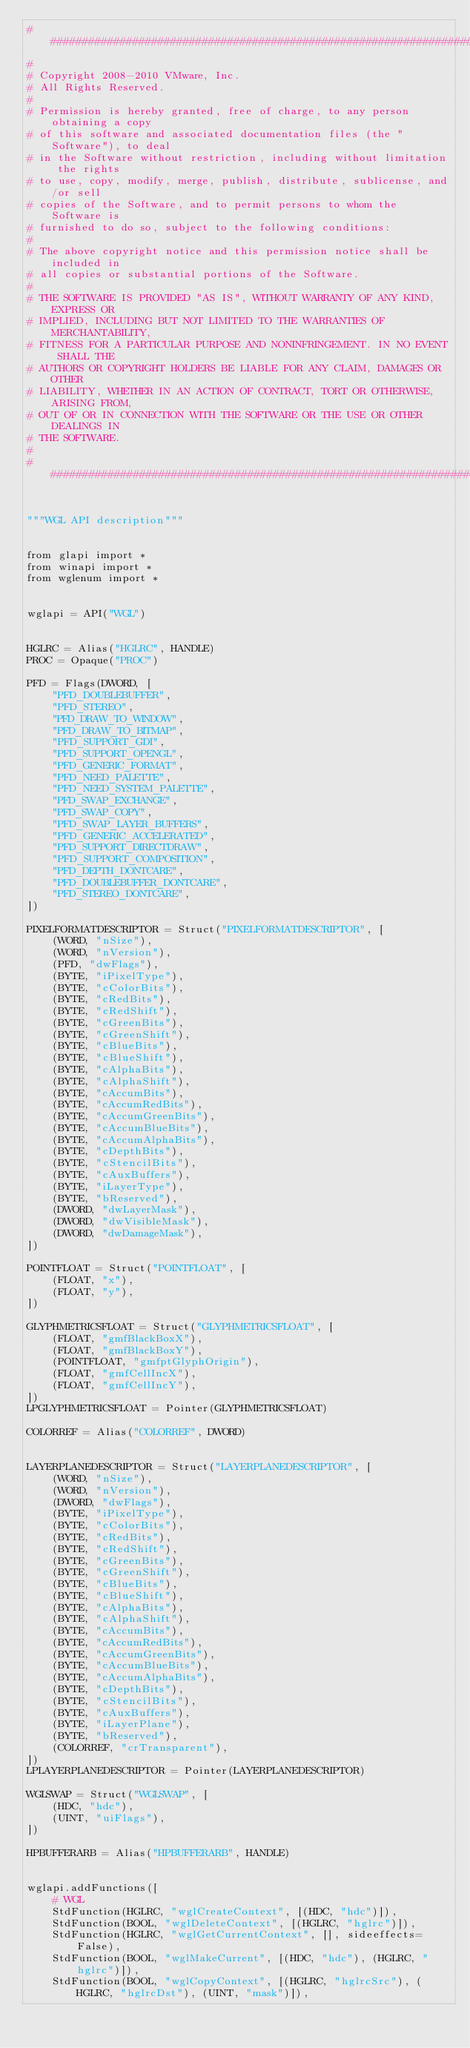Convert code to text. <code><loc_0><loc_0><loc_500><loc_500><_Python_>##########################################################################
#
# Copyright 2008-2010 VMware, Inc.
# All Rights Reserved.
#
# Permission is hereby granted, free of charge, to any person obtaining a copy
# of this software and associated documentation files (the "Software"), to deal
# in the Software without restriction, including without limitation the rights
# to use, copy, modify, merge, publish, distribute, sublicense, and/or sell
# copies of the Software, and to permit persons to whom the Software is
# furnished to do so, subject to the following conditions:
#
# The above copyright notice and this permission notice shall be included in
# all copies or substantial portions of the Software.
#
# THE SOFTWARE IS PROVIDED "AS IS", WITHOUT WARRANTY OF ANY KIND, EXPRESS OR
# IMPLIED, INCLUDING BUT NOT LIMITED TO THE WARRANTIES OF MERCHANTABILITY,
# FITNESS FOR A PARTICULAR PURPOSE AND NONINFRINGEMENT. IN NO EVENT SHALL THE
# AUTHORS OR COPYRIGHT HOLDERS BE LIABLE FOR ANY CLAIM, DAMAGES OR OTHER
# LIABILITY, WHETHER IN AN ACTION OF CONTRACT, TORT OR OTHERWISE, ARISING FROM,
# OUT OF OR IN CONNECTION WITH THE SOFTWARE OR THE USE OR OTHER DEALINGS IN
# THE SOFTWARE.
#
##########################################################################/


"""WGL API description"""


from glapi import *
from winapi import *
from wglenum import *


wglapi = API("WGL")


HGLRC = Alias("HGLRC", HANDLE)
PROC = Opaque("PROC")

PFD = Flags(DWORD, [
    "PFD_DOUBLEBUFFER",
    "PFD_STEREO",
    "PFD_DRAW_TO_WINDOW",
    "PFD_DRAW_TO_BITMAP",
    "PFD_SUPPORT_GDI",
    "PFD_SUPPORT_OPENGL",
    "PFD_GENERIC_FORMAT",
    "PFD_NEED_PALETTE",
    "PFD_NEED_SYSTEM_PALETTE",
    "PFD_SWAP_EXCHANGE",
    "PFD_SWAP_COPY",
    "PFD_SWAP_LAYER_BUFFERS",
    "PFD_GENERIC_ACCELERATED",
    "PFD_SUPPORT_DIRECTDRAW",
    "PFD_SUPPORT_COMPOSITION",
    "PFD_DEPTH_DONTCARE",
    "PFD_DOUBLEBUFFER_DONTCARE",
    "PFD_STEREO_DONTCARE",
])

PIXELFORMATDESCRIPTOR = Struct("PIXELFORMATDESCRIPTOR", [
    (WORD, "nSize"),
    (WORD, "nVersion"),
    (PFD, "dwFlags"),
    (BYTE, "iPixelType"),
    (BYTE, "cColorBits"),
    (BYTE, "cRedBits"),
    (BYTE, "cRedShift"),
    (BYTE, "cGreenBits"),
    (BYTE, "cGreenShift"),
    (BYTE, "cBlueBits"),
    (BYTE, "cBlueShift"),
    (BYTE, "cAlphaBits"),
    (BYTE, "cAlphaShift"),
    (BYTE, "cAccumBits"),
    (BYTE, "cAccumRedBits"),
    (BYTE, "cAccumGreenBits"),
    (BYTE, "cAccumBlueBits"),
    (BYTE, "cAccumAlphaBits"),
    (BYTE, "cDepthBits"),
    (BYTE, "cStencilBits"),
    (BYTE, "cAuxBuffers"),
    (BYTE, "iLayerType"),
    (BYTE, "bReserved"),
    (DWORD, "dwLayerMask"),
    (DWORD, "dwVisibleMask"),
    (DWORD, "dwDamageMask"),
])

POINTFLOAT = Struct("POINTFLOAT", [
    (FLOAT, "x"),
    (FLOAT, "y"),
])

GLYPHMETRICSFLOAT = Struct("GLYPHMETRICSFLOAT", [
    (FLOAT, "gmfBlackBoxX"),
    (FLOAT, "gmfBlackBoxY"),
    (POINTFLOAT, "gmfptGlyphOrigin"),
    (FLOAT, "gmfCellIncX"),
    (FLOAT, "gmfCellIncY"),
])
LPGLYPHMETRICSFLOAT = Pointer(GLYPHMETRICSFLOAT)

COLORREF = Alias("COLORREF", DWORD)


LAYERPLANEDESCRIPTOR = Struct("LAYERPLANEDESCRIPTOR", [
    (WORD, "nSize"),
    (WORD, "nVersion"),
    (DWORD, "dwFlags"),
    (BYTE, "iPixelType"),
    (BYTE, "cColorBits"),
    (BYTE, "cRedBits"),
    (BYTE, "cRedShift"),
    (BYTE, "cGreenBits"),
    (BYTE, "cGreenShift"),
    (BYTE, "cBlueBits"),
    (BYTE, "cBlueShift"),
    (BYTE, "cAlphaBits"),
    (BYTE, "cAlphaShift"),
    (BYTE, "cAccumBits"),
    (BYTE, "cAccumRedBits"),
    (BYTE, "cAccumGreenBits"),
    (BYTE, "cAccumBlueBits"),
    (BYTE, "cAccumAlphaBits"),
    (BYTE, "cDepthBits"),
    (BYTE, "cStencilBits"),
    (BYTE, "cAuxBuffers"),
    (BYTE, "iLayerPlane"),
    (BYTE, "bReserved"),
    (COLORREF, "crTransparent"),
])
LPLAYERPLANEDESCRIPTOR = Pointer(LAYERPLANEDESCRIPTOR)

WGLSWAP = Struct("WGLSWAP", [
    (HDC, "hdc"),
    (UINT, "uiFlags"),
])

HPBUFFERARB = Alias("HPBUFFERARB", HANDLE)


wglapi.addFunctions([
    # WGL
    StdFunction(HGLRC, "wglCreateContext", [(HDC, "hdc")]),
    StdFunction(BOOL, "wglDeleteContext", [(HGLRC, "hglrc")]),
    StdFunction(HGLRC, "wglGetCurrentContext", [], sideeffects=False),
    StdFunction(BOOL, "wglMakeCurrent", [(HDC, "hdc"), (HGLRC, "hglrc")]),
    StdFunction(BOOL, "wglCopyContext", [(HGLRC, "hglrcSrc"), (HGLRC, "hglrcDst"), (UINT, "mask")]),</code> 